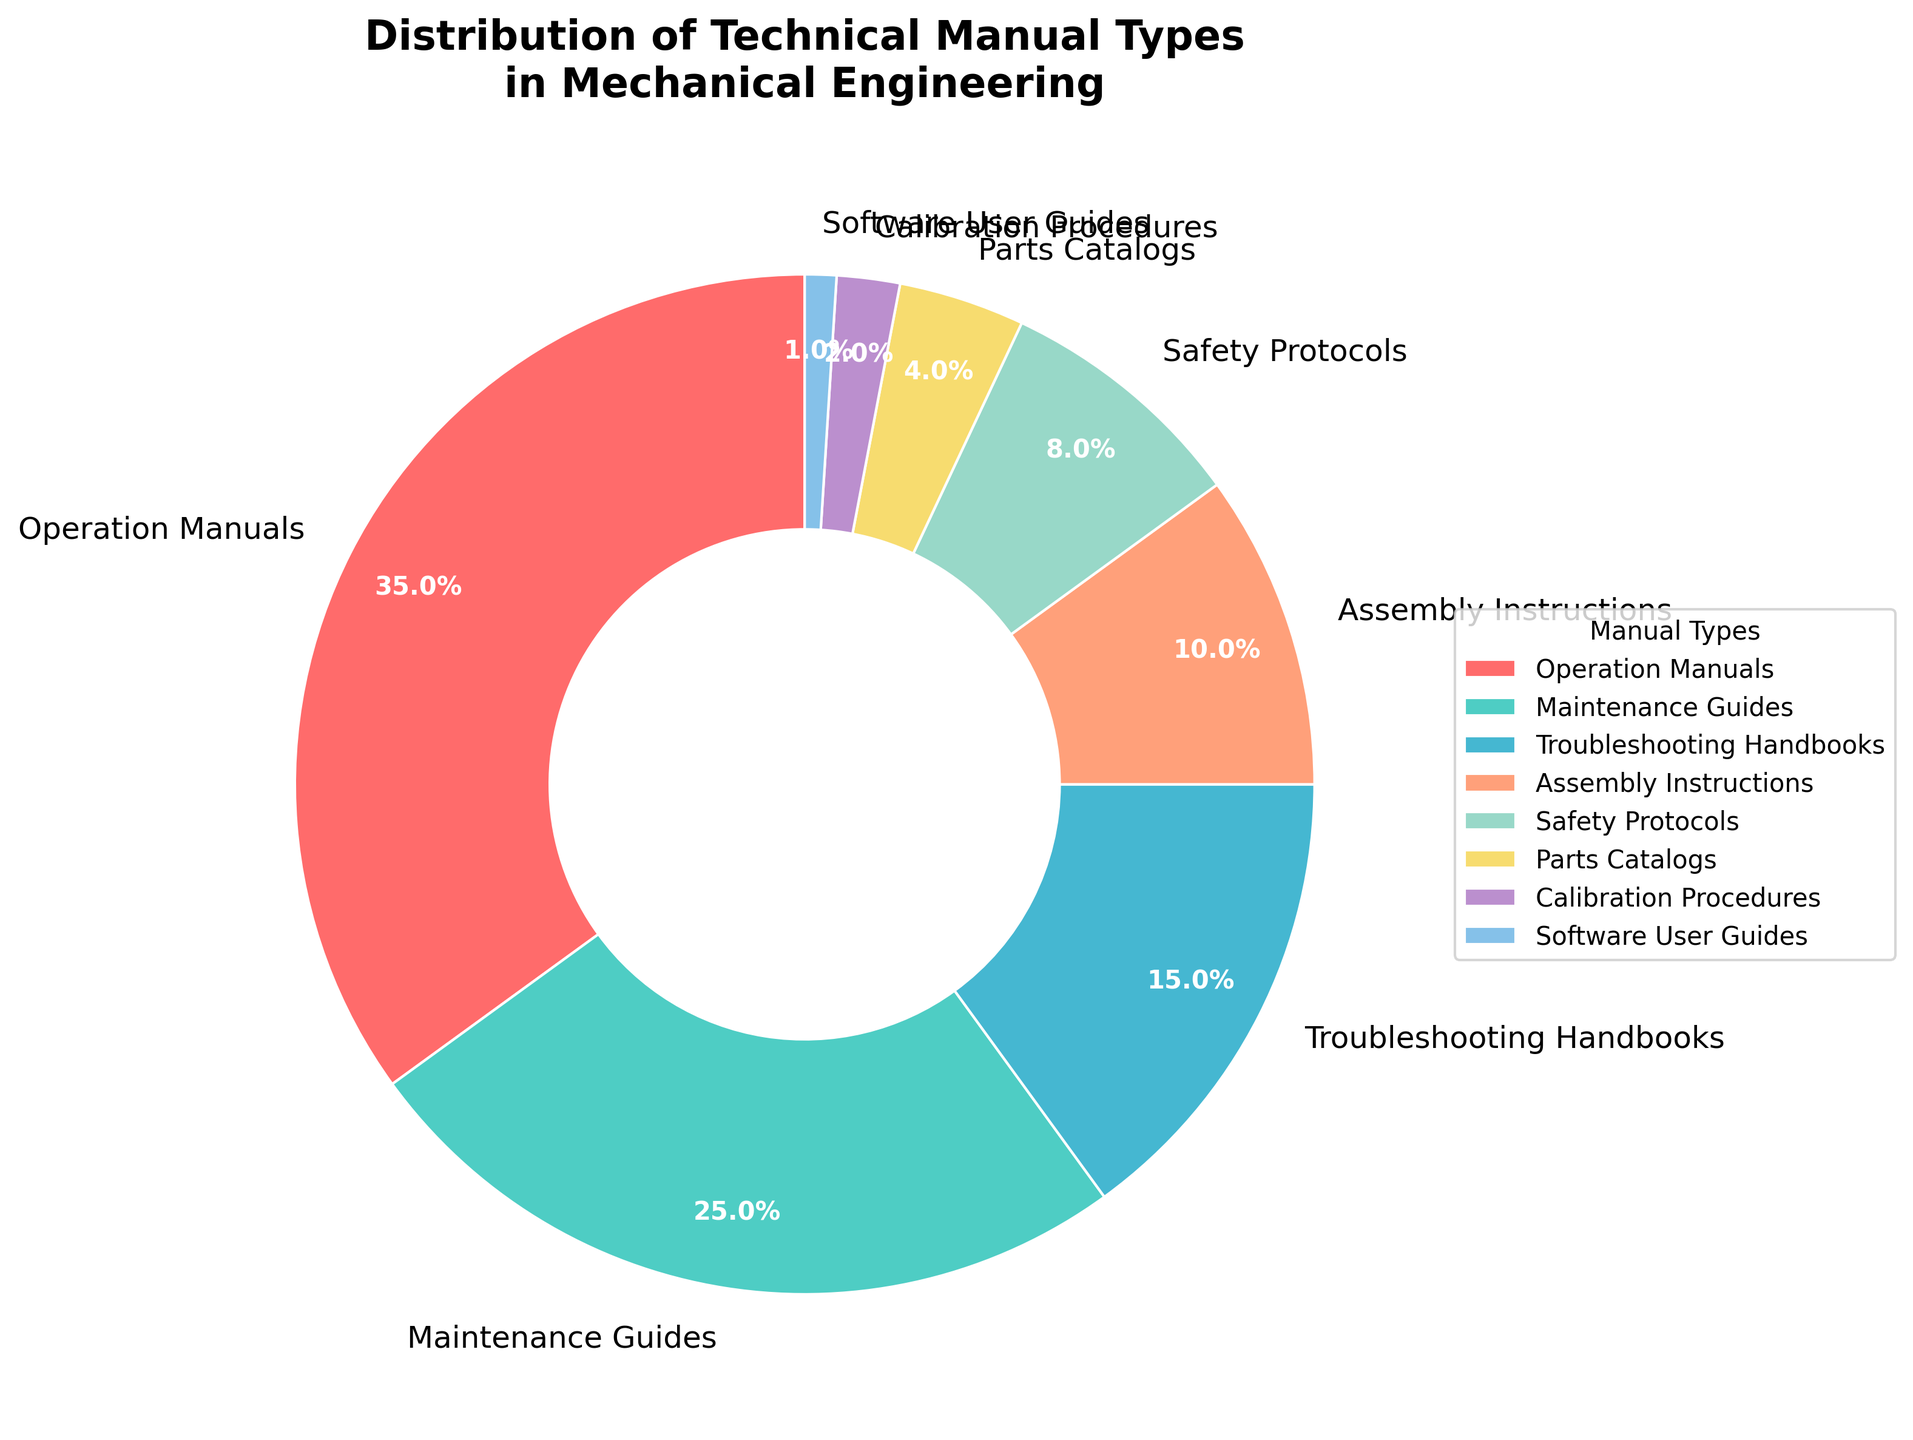What percentage of the manuals are for safety protocols? The pie chart shows the percentage of different types of manuals. To find the percentage for safety protocols, refer to the segment labeled "Safety Protocols."
Answer: 8% How does the percentage of software user guides compare to parts catalogs? The pie chart indicates that software user guides represent 1%, while parts catalogs account for 4%. Hence, software user guides are less than parts catalogs.
Answer: Less What is the combined percentage of maintenance guides and troubleshooting handbooks? In the pie chart, maintenance guides take up 25% and troubleshooting handbooks take up 15%. Adding these together, you get 25% + 15% = 40%.
Answer: 40% What manual type has the third largest share? By looking at the pie chart segments, "Troubleshooting Handbooks" is the third largest segment after "Operation Manuals" and "Maintenance Guides".
Answer: Troubleshooting Handbooks What's the difference in percentage between operation manuals and assembly instructions? The pie chart shows operation manuals at 35% and assembly instructions at 10%. Subtracting these gives 35% - 10% = 25%.
Answer: 25% Which category of manuals uses the reddish color in the plot? The pie chart uses different colors; the reddish segment corresponds to the "Operation Manuals."
Answer: Operation Manuals Are there more safety protocols or calibration procedures? The pie chart shows 8% for safety protocols and 2% for calibration procedures. Comparing these, safety protocols are more.
Answer: More What is the cumulative percentage of parts catalogs, calibration procedures, and software user guides? The pie chart shows 4% for parts catalogs, 2% for calibration procedures, and 1% for software user guides. Adding these gives 4% + 2% + 1% = 7%.
Answer: 7% Which manuals constitute more than a third of the total percentage? A third of the total is approximately 33.33%. Referring to the pie chart, "Operation Manuals," which makes up 35%, meets this criterion.
Answer: Operation Manuals How does the share of maintenance guides compare to that of safety protocols and assembly instructions combined? The pie chart shows maintenance guides at 25%, safety protocols at 8%, and assembly instructions at 10%. Adding safety protocols and assembly instructions gives 8% + 10% = 18%, which is less than 25% for maintenance guides.
Answer: More 